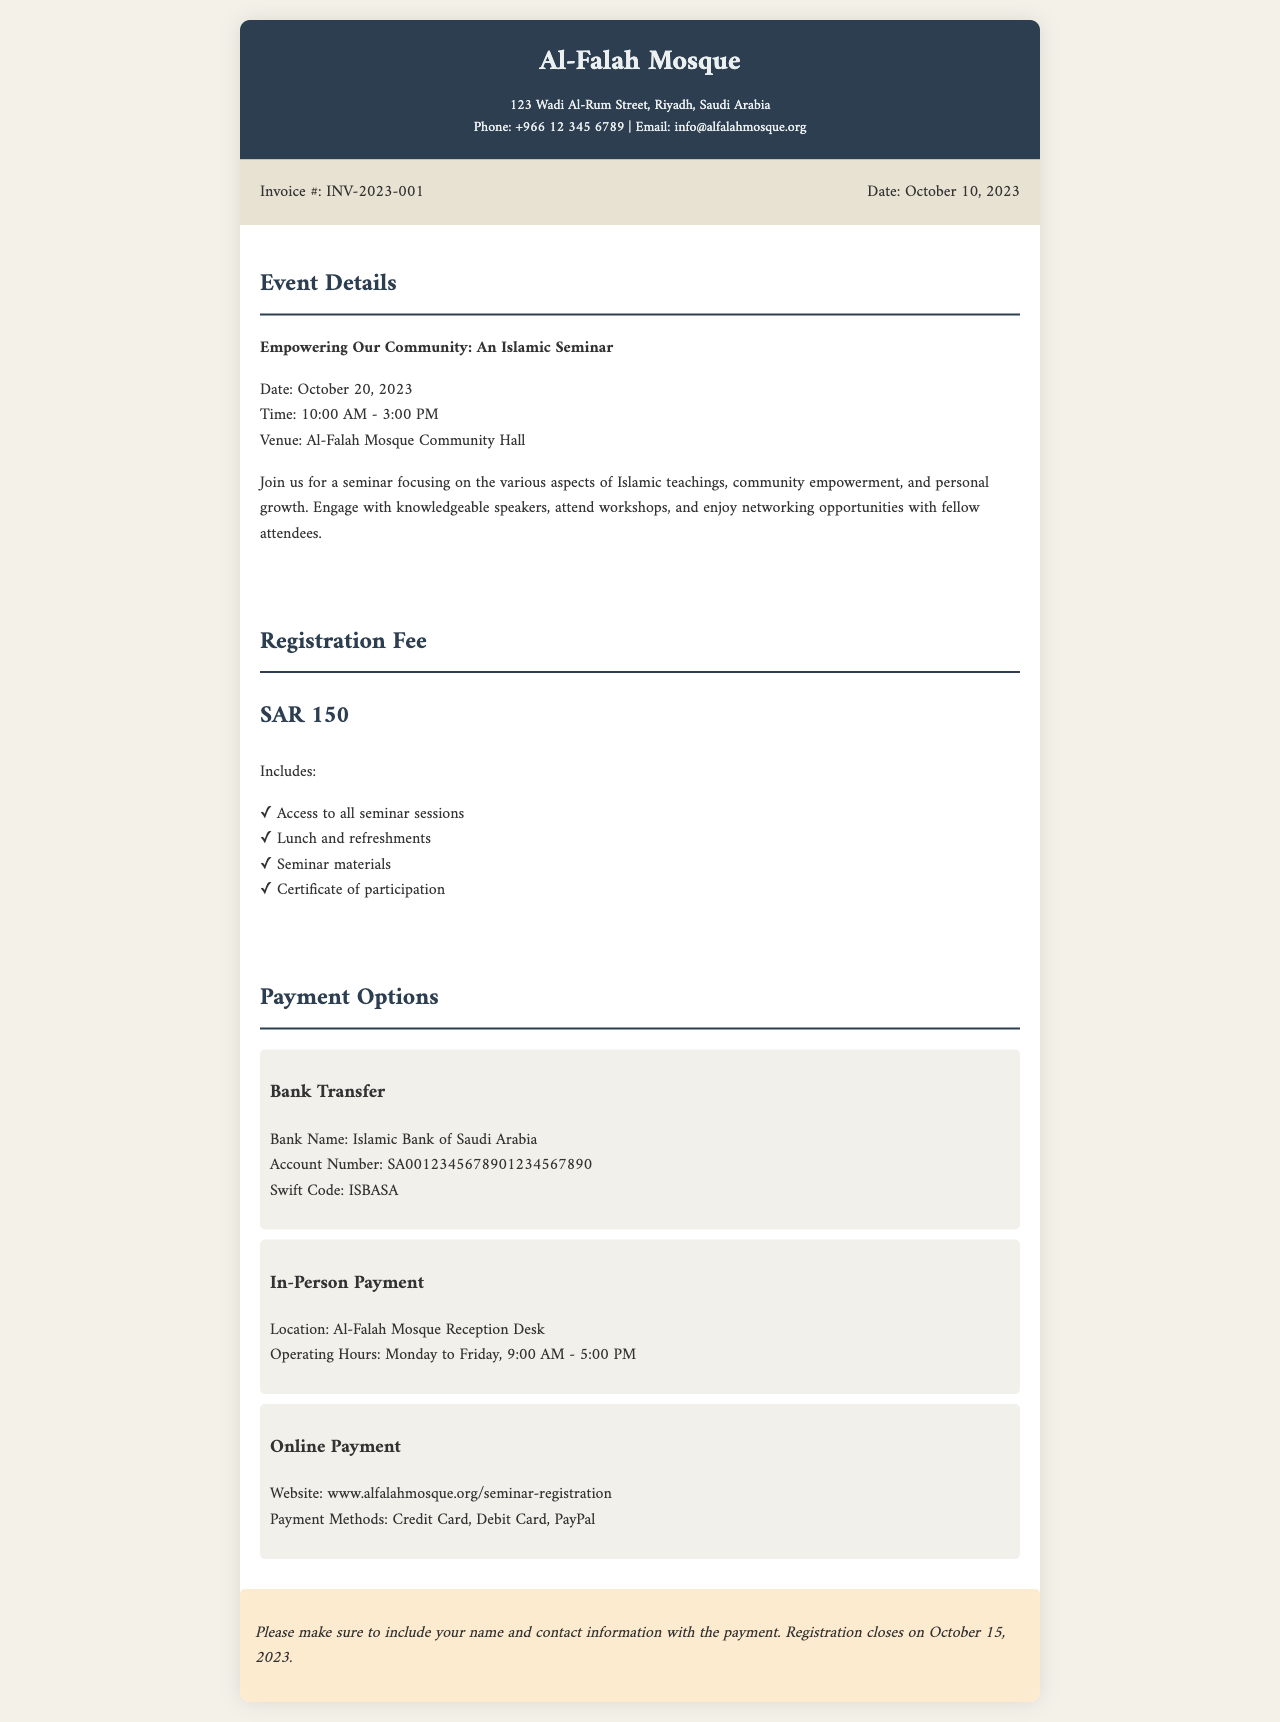What is the invoice number? The invoice number is the identifier for this specific transaction, found in the document details.
Answer: INV-2023-001 What is the registration fee? The registration fee is stated as the cost to attend the seminar, clearly mentioned in the registration fee section.
Answer: SAR 150 What is the date of the event? The date of the event is listed as when the seminar will take place, found in the event details section.
Answer: October 20, 2023 Where is the seminar venue? The venue indicates the location where the event will be held, mentioned in the event details section.
Answer: Al-Falah Mosque Community Hall What payment method allows for a transfer of funds? This payment method allows participants to transfer their registration fee directly from their bank account, as listed in the payment options section.
Answer: Bank Transfer What is included in the registration fee? The registration fee includes various items that attendees receive as part of their package, listed under the registration fee section.
Answer: Access to all seminar sessions, Lunch and refreshments, Seminar materials, Certificate of participation What is the registration deadline? The registration deadline informs participants of the last day they can sign up for the seminar, noted in the document.
Answer: October 15, 2023 What are the operating hours for in-person payment? This provides the hours when attendees can make payments directly at the mosque, as mentioned in the payment options section.
Answer: Monday to Friday, 9:00 AM - 5:00 PM 